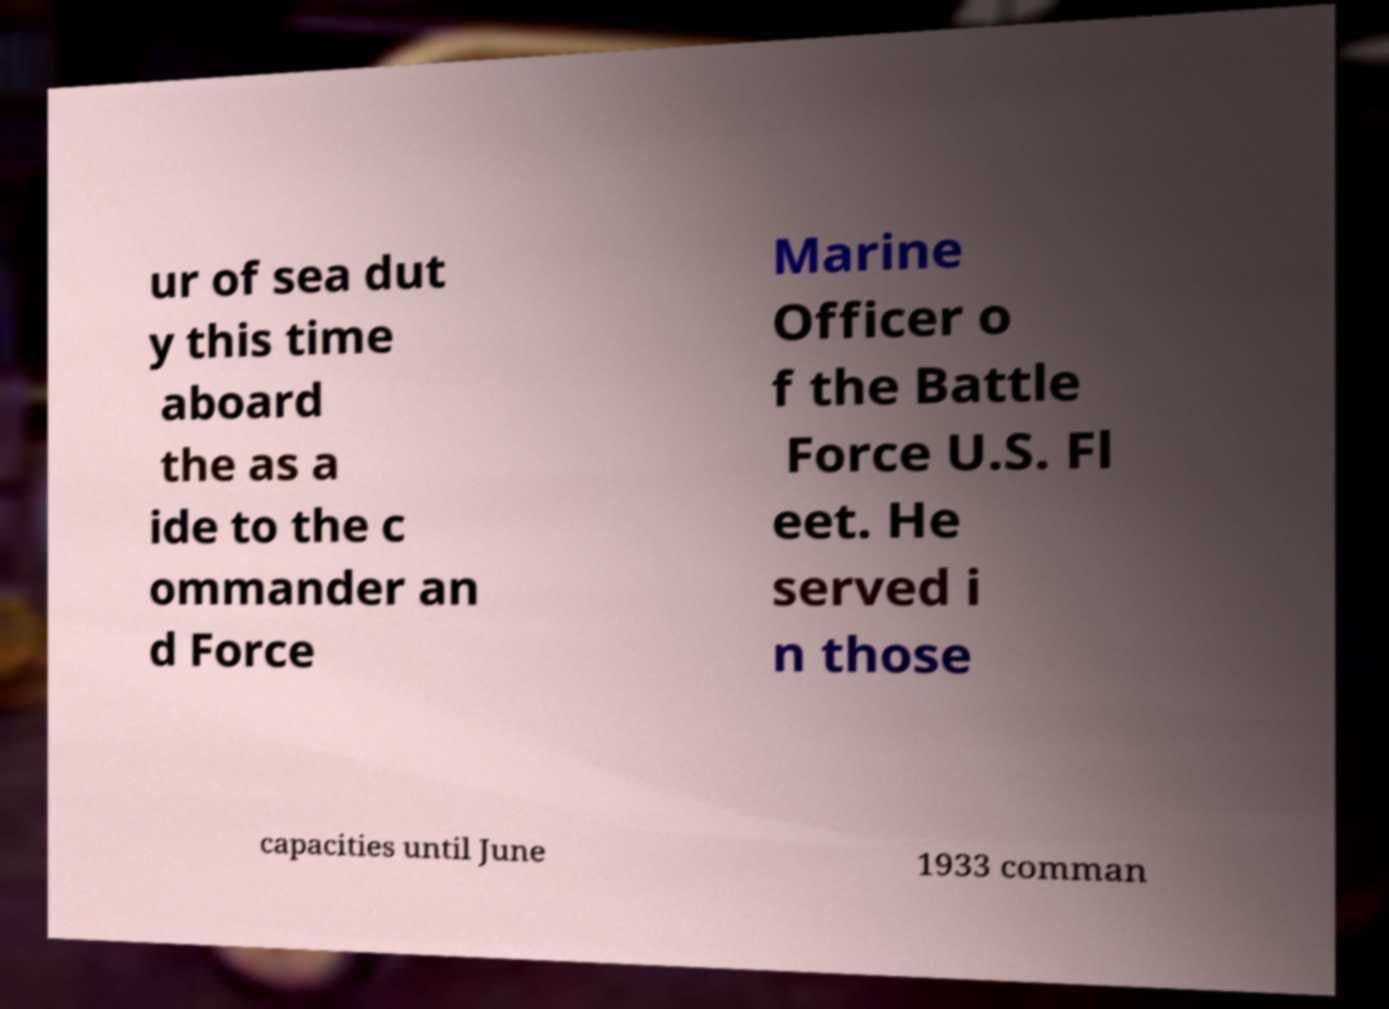Please read and relay the text visible in this image. What does it say? ur of sea dut y this time aboard the as a ide to the c ommander an d Force Marine Officer o f the Battle Force U.S. Fl eet. He served i n those capacities until June 1933 comman 